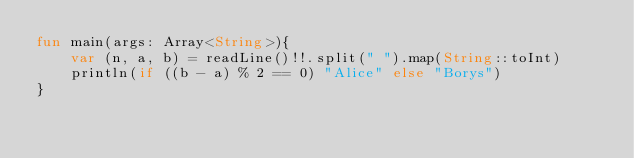<code> <loc_0><loc_0><loc_500><loc_500><_Kotlin_>fun main(args: Array<String>){
    var (n, a, b) = readLine()!!.split(" ").map(String::toInt)
    println(if ((b - a) % 2 == 0) "Alice" else "Borys")
}
</code> 